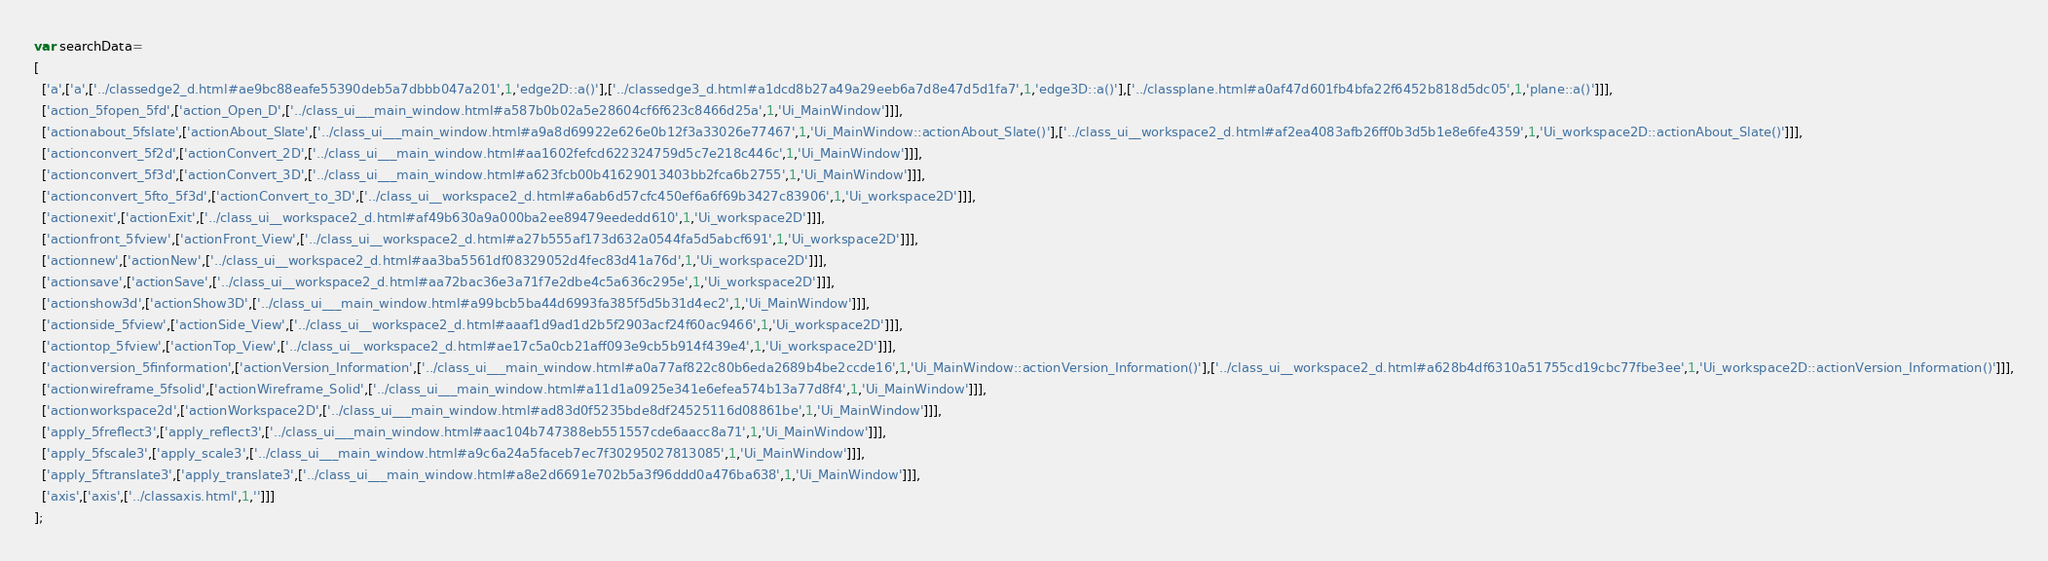<code> <loc_0><loc_0><loc_500><loc_500><_JavaScript_>var searchData=
[
  ['a',['a',['../classedge2_d.html#ae9bc88eafe55390deb5a7dbbb047a201',1,'edge2D::a()'],['../classedge3_d.html#a1dcd8b27a49a29eeb6a7d8e47d5d1fa7',1,'edge3D::a()'],['../classplane.html#a0af47d601fb4bfa22f6452b818d5dc05',1,'plane::a()']]],
  ['action_5fopen_5fd',['action_Open_D',['../class_ui___main_window.html#a587b0b02a5e28604cf6f623c8466d25a',1,'Ui_MainWindow']]],
  ['actionabout_5fslate',['actionAbout_Slate',['../class_ui___main_window.html#a9a8d69922e626e0b12f3a33026e77467',1,'Ui_MainWindow::actionAbout_Slate()'],['../class_ui__workspace2_d.html#af2ea4083afb26ff0b3d5b1e8e6fe4359',1,'Ui_workspace2D::actionAbout_Slate()']]],
  ['actionconvert_5f2d',['actionConvert_2D',['../class_ui___main_window.html#aa1602fefcd622324759d5c7e218c446c',1,'Ui_MainWindow']]],
  ['actionconvert_5f3d',['actionConvert_3D',['../class_ui___main_window.html#a623fcb00b41629013403bb2fca6b2755',1,'Ui_MainWindow']]],
  ['actionconvert_5fto_5f3d',['actionConvert_to_3D',['../class_ui__workspace2_d.html#a6ab6d57cfc450ef6a6f69b3427c83906',1,'Ui_workspace2D']]],
  ['actionexit',['actionExit',['../class_ui__workspace2_d.html#af49b630a9a000ba2ee89479eededd610',1,'Ui_workspace2D']]],
  ['actionfront_5fview',['actionFront_View',['../class_ui__workspace2_d.html#a27b555af173d632a0544fa5d5abcf691',1,'Ui_workspace2D']]],
  ['actionnew',['actionNew',['../class_ui__workspace2_d.html#aa3ba5561df08329052d4fec83d41a76d',1,'Ui_workspace2D']]],
  ['actionsave',['actionSave',['../class_ui__workspace2_d.html#aa72bac36e3a71f7e2dbe4c5a636c295e',1,'Ui_workspace2D']]],
  ['actionshow3d',['actionShow3D',['../class_ui___main_window.html#a99bcb5ba44d6993fa385f5d5b31d4ec2',1,'Ui_MainWindow']]],
  ['actionside_5fview',['actionSide_View',['../class_ui__workspace2_d.html#aaaf1d9ad1d2b5f2903acf24f60ac9466',1,'Ui_workspace2D']]],
  ['actiontop_5fview',['actionTop_View',['../class_ui__workspace2_d.html#ae17c5a0cb21aff093e9cb5b914f439e4',1,'Ui_workspace2D']]],
  ['actionversion_5finformation',['actionVersion_Information',['../class_ui___main_window.html#a0a77af822c80b6eda2689b4be2ccde16',1,'Ui_MainWindow::actionVersion_Information()'],['../class_ui__workspace2_d.html#a628b4df6310a51755cd19cbc77fbe3ee',1,'Ui_workspace2D::actionVersion_Information()']]],
  ['actionwireframe_5fsolid',['actionWireframe_Solid',['../class_ui___main_window.html#a11d1a0925e341e6efea574b13a77d8f4',1,'Ui_MainWindow']]],
  ['actionworkspace2d',['actionWorkspace2D',['../class_ui___main_window.html#ad83d0f5235bde8df24525116d08861be',1,'Ui_MainWindow']]],
  ['apply_5freflect3',['apply_reflect3',['../class_ui___main_window.html#aac104b747388eb551557cde6aacc8a71',1,'Ui_MainWindow']]],
  ['apply_5fscale3',['apply_scale3',['../class_ui___main_window.html#a9c6a24a5faceb7ec7f30295027813085',1,'Ui_MainWindow']]],
  ['apply_5ftranslate3',['apply_translate3',['../class_ui___main_window.html#a8e2d6691e702b5a3f96ddd0a476ba638',1,'Ui_MainWindow']]],
  ['axis',['axis',['../classaxis.html',1,'']]]
];
</code> 